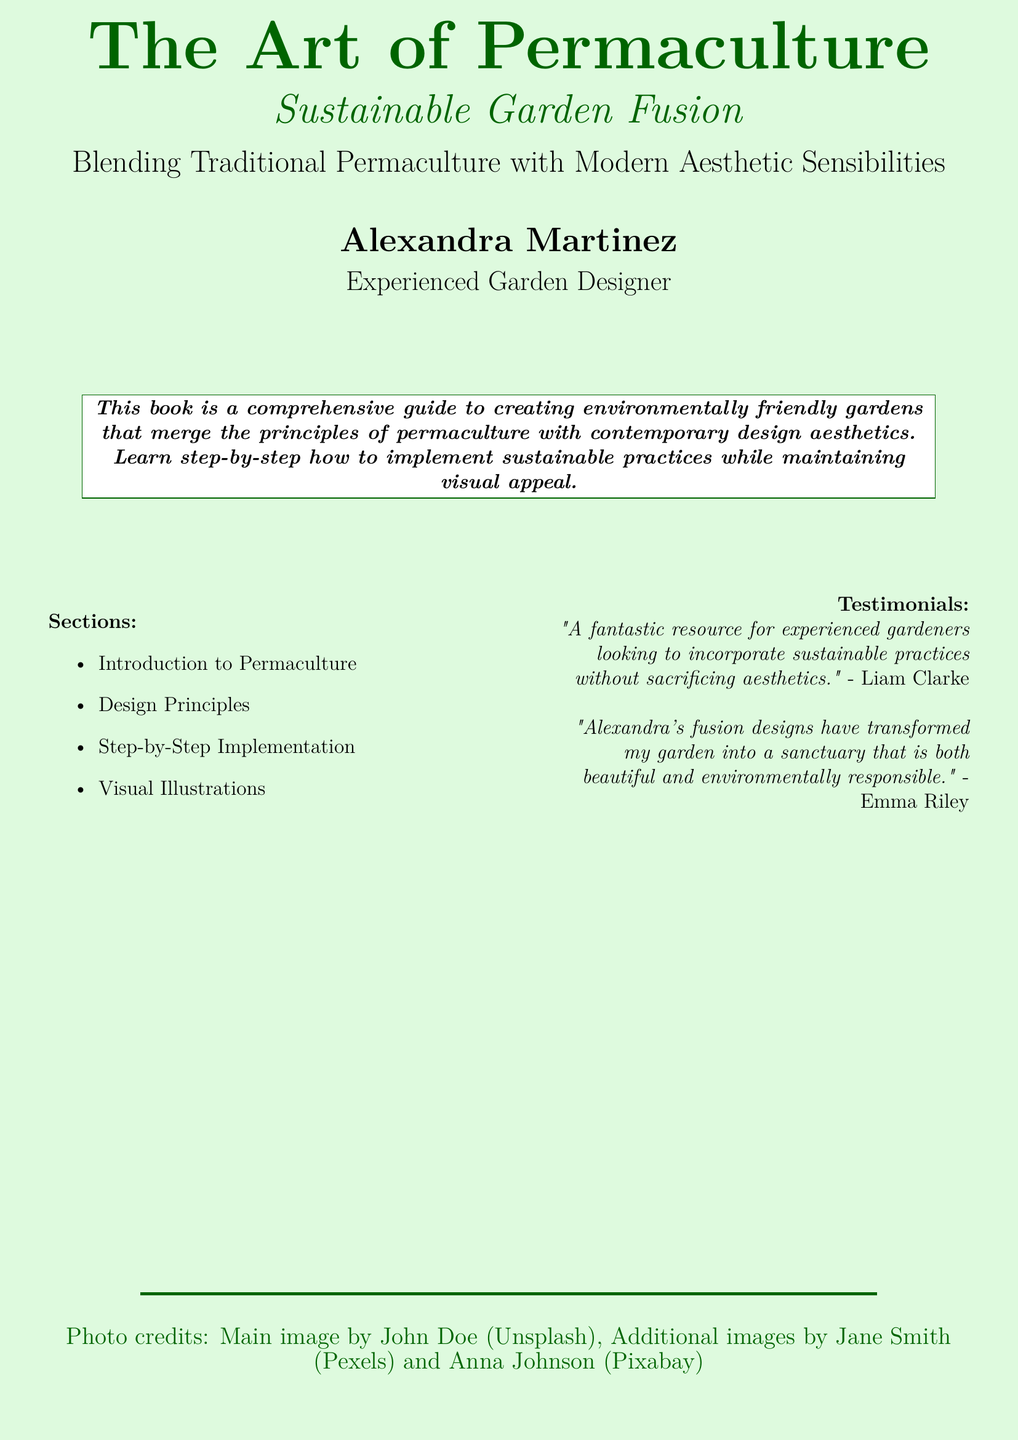What is the title of the book? The title is prominently displayed on the cover and offers a clear identification of the book.
Answer: The Art of Permaculture Who is the author of the book? The author's name is listed at the bottom of the cover, providing credit to the creator of the content.
Answer: Alexandra Martinez What is the main focus of the book? The main focus is highlighted in the subtitle, giving insight into the book's content and themes.
Answer: Sustainable Garden Fusion How many sections are listed in the document? The sections are enumerated in the cover design, indicating the structure of the book.
Answer: Four What is one of the testimonials provided? The testimonials section features praises from readers, reflecting their experiences with the content.
Answer: "A fantastic resource for experienced gardeners looking to incorporate sustainable practices without sacrificing aesthetics." What color scheme is used in the background of the document? The background color is an important part of the document's design, enhancing visual appeal.
Answer: Light green What is the occupation of the author? The author’s profession is specified under her name, which indicates her expertise.
Answer: Experienced Garden Designer 